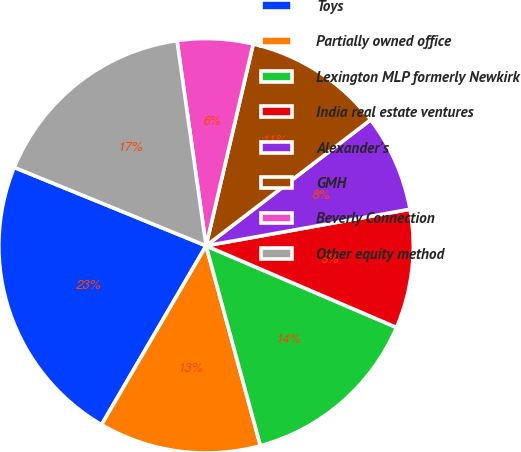<chart> <loc_0><loc_0><loc_500><loc_500><pie_chart><fcel>Toys<fcel>Partially owned office<fcel>Lexington MLP formerly Newkirk<fcel>India real estate ventures<fcel>Alexander's<fcel>GMH<fcel>Beverly Connection<fcel>Other equity method<nl><fcel>22.76%<fcel>12.64%<fcel>14.33%<fcel>9.27%<fcel>7.58%<fcel>10.95%<fcel>5.89%<fcel>16.59%<nl></chart> 